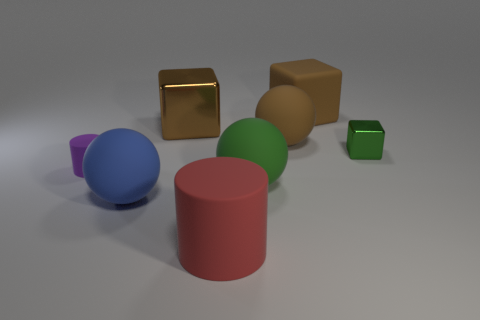Add 2 red cylinders. How many objects exist? 10 Subtract all blocks. How many objects are left? 5 Subtract all big objects. Subtract all cyan spheres. How many objects are left? 2 Add 2 green rubber balls. How many green rubber balls are left? 3 Add 4 small red shiny cylinders. How many small red shiny cylinders exist? 4 Subtract 0 cyan spheres. How many objects are left? 8 